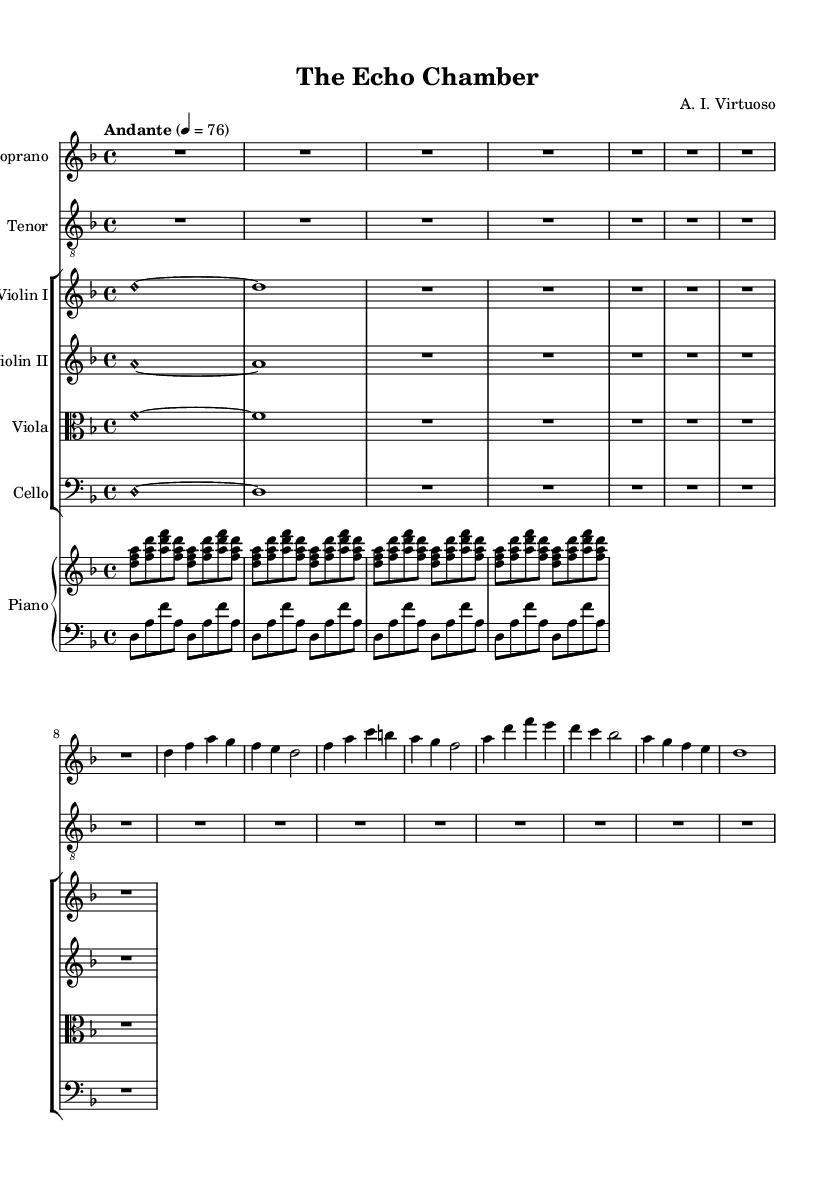What is the key signature of this music? The key signature is identified at the beginning of the score. The presence of B flat indicates it's in the D minor key signature, which has one flat.
Answer: D minor What is the time signature of this composition? The time signature can be found at the start of the score. It is indicated as 4/4, meaning there are four beats in each measure and the quarter note gets one beat.
Answer: 4/4 What is the tempo marking for the piece? The tempo marking appears above the music staff and indicates the speed of the piece. In this case, "Andante" suggests a moderate pace, specifically at a metronome marking of 76.
Answer: Andante How many measures are in the soprano part? To count the measures, one can simply look at the notation for the soprano, which shows the beginning and the end of each measure. There are eight measures present in the soprano part.
Answer: Eight What instruments are included in the ensemble? An overview of the score's layout shows which instruments are listed. The ensemble consists of Soprano, Tenor, Violin I, Violin II, Viola, Cello, and Piano.
Answer: Soprano, Tenor, Violin I, Violin II, Viola, Cello, Piano What is the primary theme addressed in the lyrics of the soprano? By reading the lyrics provided for the soprano, one can interpret that the theme revolves around contrasting traditional media with digital forms, emphasizing the influence of echo chambers in communication.
Answer: Echo chambers in communication 